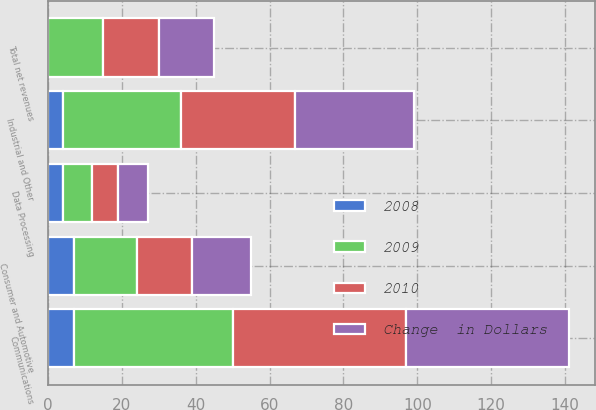<chart> <loc_0><loc_0><loc_500><loc_500><stacked_bar_chart><ecel><fcel>Communications<fcel>Industrial and Other<fcel>Consumer and Automotive<fcel>Data Processing<fcel>Total net revenues<nl><fcel>2010<fcel>47<fcel>31<fcel>15<fcel>7<fcel>15<nl><fcel>2008<fcel>7<fcel>4<fcel>7<fcel>4<fcel>0<nl><fcel>Change  in Dollars<fcel>44<fcel>32<fcel>16<fcel>8<fcel>15<nl><fcel>2009<fcel>43<fcel>32<fcel>17<fcel>8<fcel>15<nl></chart> 